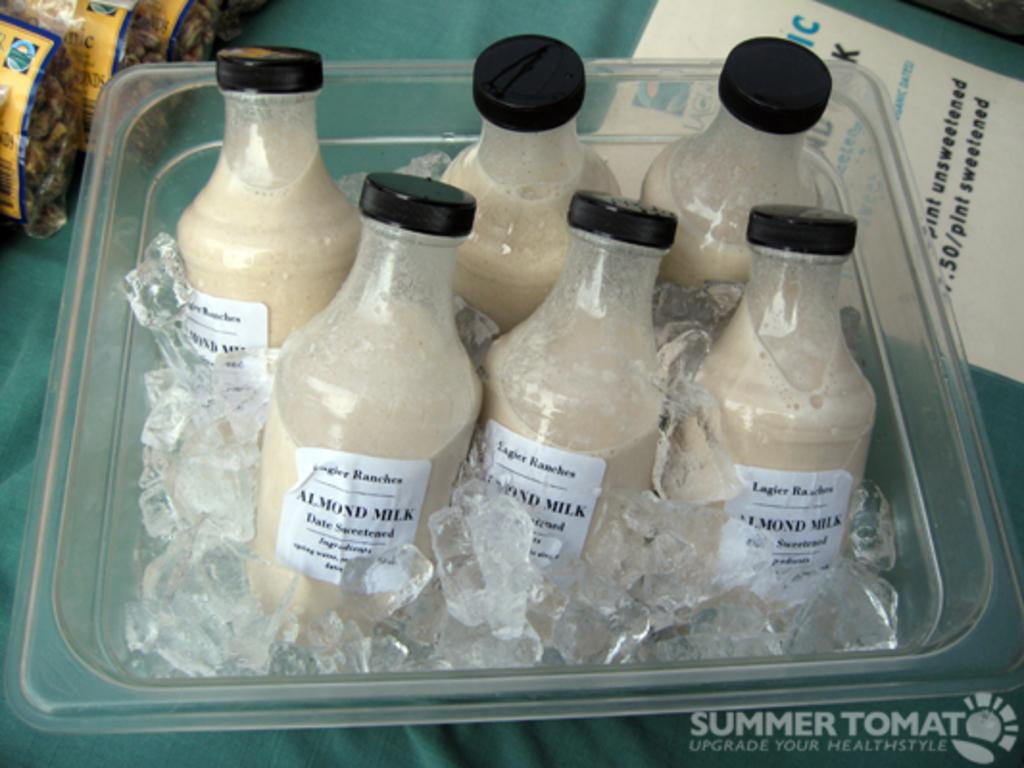<image>
Give a short and clear explanation of the subsequent image. Several bottles of almond milk are in a container with ice. 